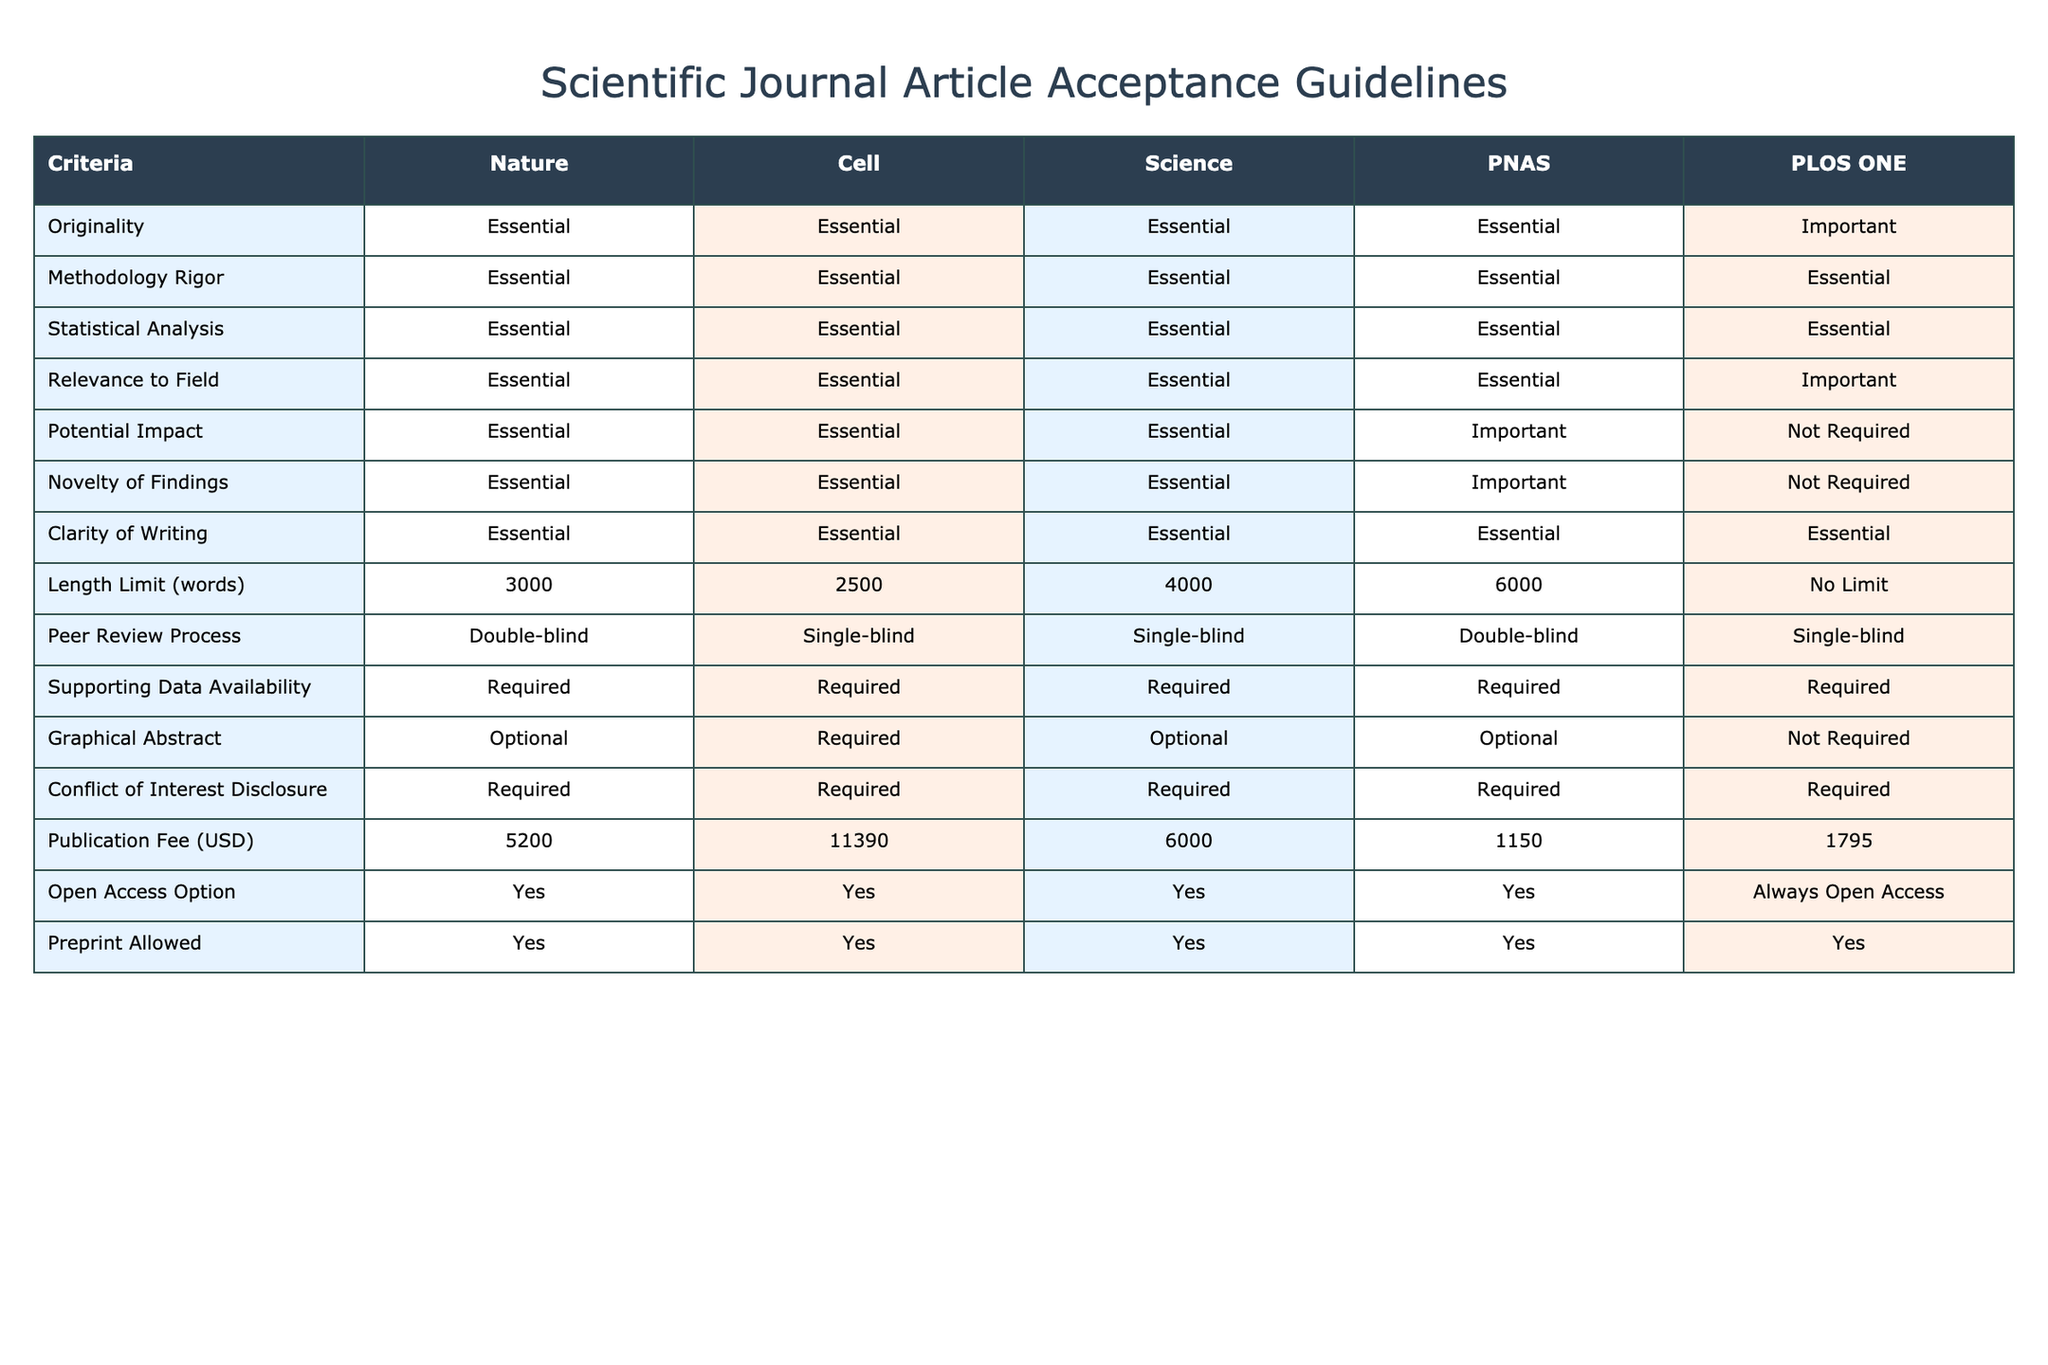What is the publication fee for PNAS? The publication fee for PNAS is listed in the table under the "Publication Fee (USD)" column, which indicates that it is 6000 USD.
Answer: 6000 USD Is the peer review process for Nature double-blind? The table indicates that the peer review process for Nature is double-blind as noted in the "Peer Review Process" row.
Answer: Yes In how many journals is 'Clarity of Writing' deemed essential? The table shows that 'Clarity of Writing' is marked as essential for all journals listed (Nature, Cell, Science, PNAS), which totals four journals.
Answer: 4 What is the total number of journals that require a graphical abstract? From the table, we see that Cell (required), Nature (optional), and Science (optional) show a mix of requirements, but only Cell requires it. Thus, only one journal mandates it directly.
Answer: 1 Which journal has the highest publication fee? By reviewing the "Publication Fee (USD)" column, we find that Cell has the highest fee at 11390 USD.
Answer: Cell How does the average publication fee of high-impact journals (Nature, Cell, Science) compare to that of PLOS ONE? Calculating the average for high-impact journals (Nature 5200 + Cell 11390 + Science 6000 = 22590), we divide it by 3, resulting in 7520. PLOS ONE's fee is 1795, making it significantly lower than the average of the others.
Answer: PLOS ONE is lower For which journal(s) is having supporting data availability required? The table indicates that supporting data availability is a requirement for all journals listed (Nature, Cell, Science, PNAS, PLOS ONE), confirming they all necessitate this aspect.
Answer: All journals If a researcher is considering submitting to a journal without a word limit, which journal should they choose? The table shows "No Limit" under the "Length Limit (words)" column for PLOS ONE, indicating this journal does not impose a limit on word count.
Answer: PLOS ONE What is the difference in publication fees between Nature and PLOS ONE? The publication fee for Nature is 5200 USD, and for PLOS ONE, it is 1795 USD. The difference is 5200 - 1795 = 3405 USD.
Answer: 3405 USD Which journals allow preprints? The table shows that all journals (Nature, Cell, Science, PNAS, PLOS ONE) allow preprints, as each has "Yes" listed under the "Preprint Allowed" column.
Answer: All journals 